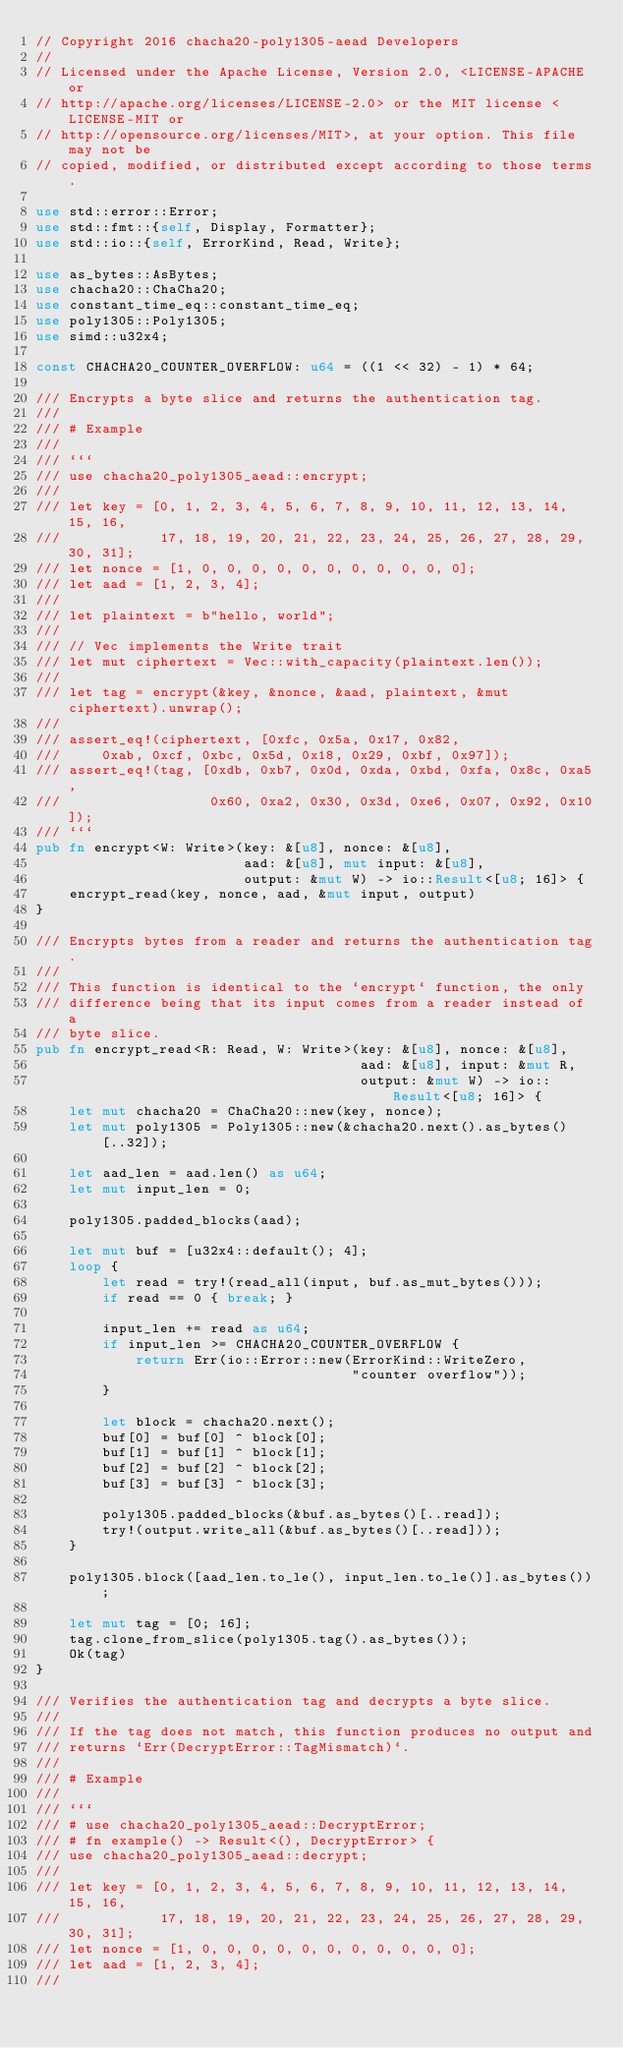Convert code to text. <code><loc_0><loc_0><loc_500><loc_500><_Rust_>// Copyright 2016 chacha20-poly1305-aead Developers
//
// Licensed under the Apache License, Version 2.0, <LICENSE-APACHE or
// http://apache.org/licenses/LICENSE-2.0> or the MIT license <LICENSE-MIT or
// http://opensource.org/licenses/MIT>, at your option. This file may not be
// copied, modified, or distributed except according to those terms.

use std::error::Error;
use std::fmt::{self, Display, Formatter};
use std::io::{self, ErrorKind, Read, Write};

use as_bytes::AsBytes;
use chacha20::ChaCha20;
use constant_time_eq::constant_time_eq;
use poly1305::Poly1305;
use simd::u32x4;

const CHACHA20_COUNTER_OVERFLOW: u64 = ((1 << 32) - 1) * 64;

/// Encrypts a byte slice and returns the authentication tag.
///
/// # Example
///
/// ```
/// use chacha20_poly1305_aead::encrypt;
///
/// let key = [0, 1, 2, 3, 4, 5, 6, 7, 8, 9, 10, 11, 12, 13, 14, 15, 16,
///            17, 18, 19, 20, 21, 22, 23, 24, 25, 26, 27, 28, 29, 30, 31];
/// let nonce = [1, 0, 0, 0, 0, 0, 0, 0, 0, 0, 0, 0];
/// let aad = [1, 2, 3, 4];
///
/// let plaintext = b"hello, world";
///
/// // Vec implements the Write trait
/// let mut ciphertext = Vec::with_capacity(plaintext.len());
///
/// let tag = encrypt(&key, &nonce, &aad, plaintext, &mut ciphertext).unwrap();
///
/// assert_eq!(ciphertext, [0xfc, 0x5a, 0x17, 0x82,
///     0xab, 0xcf, 0xbc, 0x5d, 0x18, 0x29, 0xbf, 0x97]);
/// assert_eq!(tag, [0xdb, 0xb7, 0x0d, 0xda, 0xbd, 0xfa, 0x8c, 0xa5,
///                  0x60, 0xa2, 0x30, 0x3d, 0xe6, 0x07, 0x92, 0x10]);
/// ```
pub fn encrypt<W: Write>(key: &[u8], nonce: &[u8],
                         aad: &[u8], mut input: &[u8],
                         output: &mut W) -> io::Result<[u8; 16]> {
    encrypt_read(key, nonce, aad, &mut input, output)
}

/// Encrypts bytes from a reader and returns the authentication tag.
///
/// This function is identical to the `encrypt` function, the only
/// difference being that its input comes from a reader instead of a
/// byte slice.
pub fn encrypt_read<R: Read, W: Write>(key: &[u8], nonce: &[u8],
                                       aad: &[u8], input: &mut R,
                                       output: &mut W) -> io::Result<[u8; 16]> {
    let mut chacha20 = ChaCha20::new(key, nonce);
    let mut poly1305 = Poly1305::new(&chacha20.next().as_bytes()[..32]);

    let aad_len = aad.len() as u64;
    let mut input_len = 0;

    poly1305.padded_blocks(aad);

    let mut buf = [u32x4::default(); 4];
    loop {
        let read = try!(read_all(input, buf.as_mut_bytes()));
        if read == 0 { break; }

        input_len += read as u64;
        if input_len >= CHACHA20_COUNTER_OVERFLOW {
            return Err(io::Error::new(ErrorKind::WriteZero,
                                      "counter overflow"));
        }

        let block = chacha20.next();
        buf[0] = buf[0] ^ block[0];
        buf[1] = buf[1] ^ block[1];
        buf[2] = buf[2] ^ block[2];
        buf[3] = buf[3] ^ block[3];

        poly1305.padded_blocks(&buf.as_bytes()[..read]);
        try!(output.write_all(&buf.as_bytes()[..read]));
    }

    poly1305.block([aad_len.to_le(), input_len.to_le()].as_bytes());

    let mut tag = [0; 16];
    tag.clone_from_slice(poly1305.tag().as_bytes());
    Ok(tag)
}

/// Verifies the authentication tag and decrypts a byte slice.
///
/// If the tag does not match, this function produces no output and
/// returns `Err(DecryptError::TagMismatch)`.
///
/// # Example
///
/// ```
/// # use chacha20_poly1305_aead::DecryptError;
/// # fn example() -> Result<(), DecryptError> {
/// use chacha20_poly1305_aead::decrypt;
///
/// let key = [0, 1, 2, 3, 4, 5, 6, 7, 8, 9, 10, 11, 12, 13, 14, 15, 16,
///            17, 18, 19, 20, 21, 22, 23, 24, 25, 26, 27, 28, 29, 30, 31];
/// let nonce = [1, 0, 0, 0, 0, 0, 0, 0, 0, 0, 0, 0];
/// let aad = [1, 2, 3, 4];
///</code> 